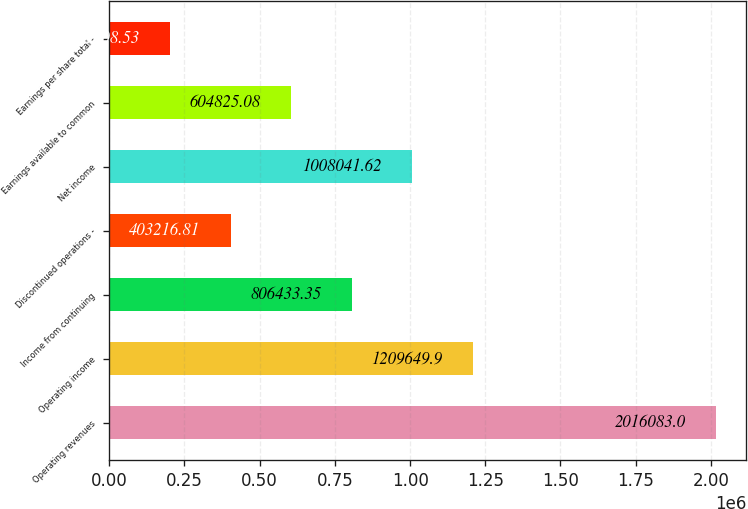<chart> <loc_0><loc_0><loc_500><loc_500><bar_chart><fcel>Operating revenues<fcel>Operating income<fcel>Income from continuing<fcel>Discontinued operations -<fcel>Net income<fcel>Earnings available to common<fcel>Earnings per share total -<nl><fcel>2.01608e+06<fcel>1.20965e+06<fcel>806433<fcel>403217<fcel>1.00804e+06<fcel>604825<fcel>201609<nl></chart> 